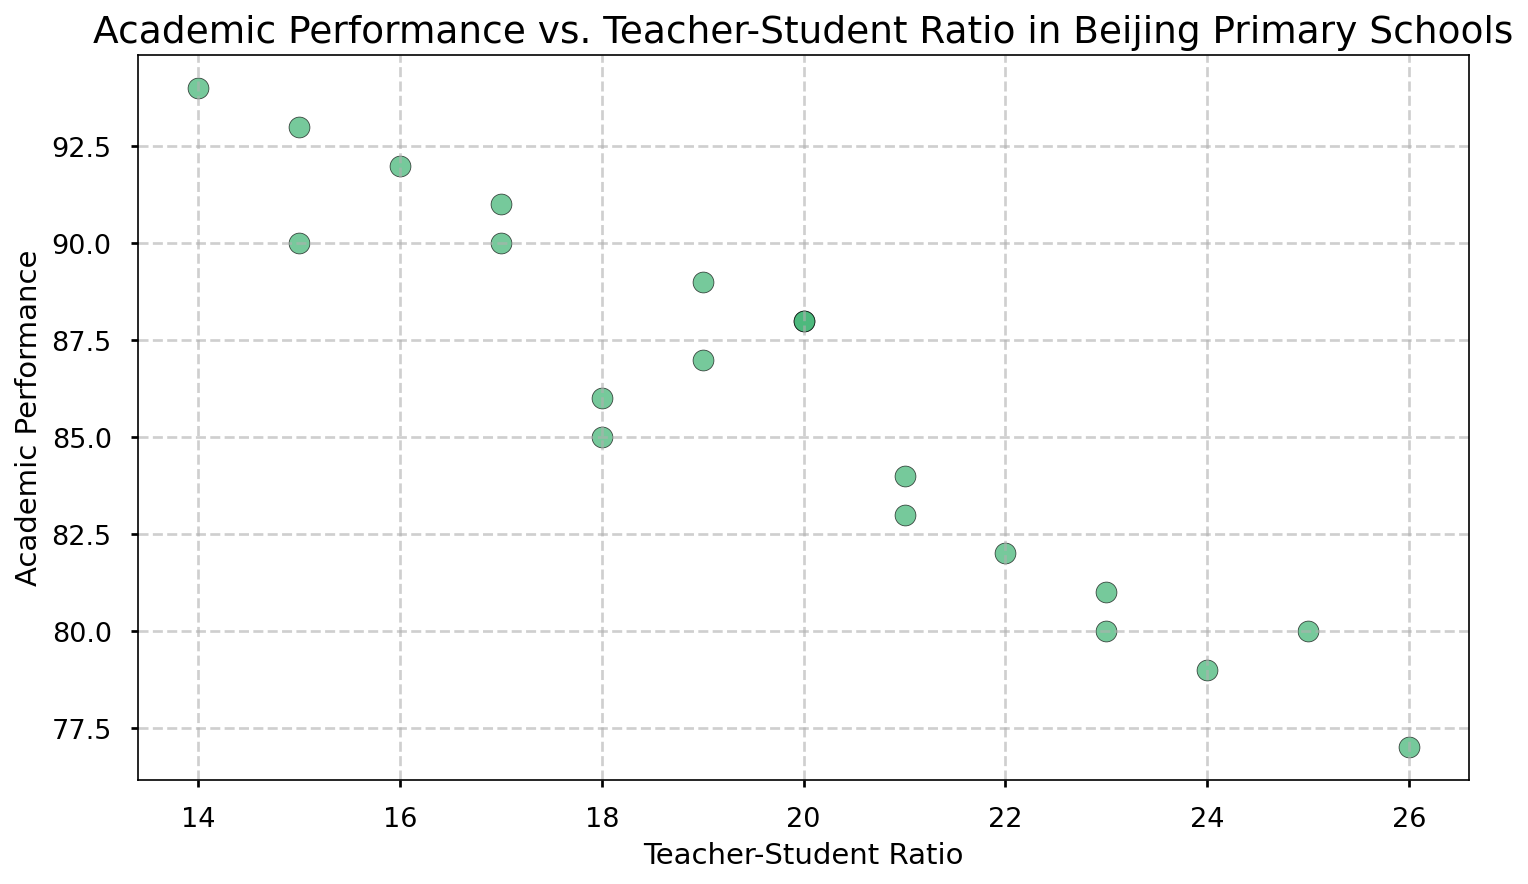What's the relationship between Teacher-Student Ratio and Academic Performance in the scatter plot? The scatter plot shows how Teacher-Student Ratio and Academic Performance vary among Beijing primary schools. By observing the trend in the data points, a general pattern can be discerned, where lower Teacher-Student Ratios tend to correlate with higher Academic Performance. This is evident as schools with lower ratios, such as 14 or 15, generally show higher performance values like 94 and 93.
Answer: Lower Ratio, Higher Performance Which school has the highest Academic Performance, and what is its Teacher-Student Ratio? By identifying the data point with the highest y-coordinate (Academic Performance) in the scatter plot, we see that Beijing Primary School G has the highest Academic Performance of 94. Its Teacher-Student Ratio (x-coordinate) is 14.
Answer: Beijing Primary School G, Ratio: 14 Which schools have Academic Performance above 90, and what are their Teacher-Student Ratios? In the scatter plot, data points above the 90 on the y-axis are noted. The corresponding Teacher-Student Ratios for these data points are then identified: School G (14), School F (16), School K (17), School A (15), and School P (15).
Answer: Schools: G, F, K, A, P; Ratios: 14, 16, 17, 15, 15 Is there a significant difference in Academic Performance between schools with Teacher-Student Ratios of 20 and 25? Observing the data points corresponding to Teacher-Student Ratios of 20 and 25, we see that schools at the ratio of 20 have Academic Performances of 88 and 88 (Schools C and N), whereas schools at the ratio of 25 have a performance of 80 (School D). The difference is noticeable: 88 - 80 = 8 points.
Answer: 8 points Which school has both the lowest Academic Performance and the highest Teacher-Student Ratio? By finding the data point with the lowest y-coordinate (Academic Performance) and highest x-coordinate (Teacher-Student Ratio) simultaneously, we determine that Beijing Primary School O has the lowest performance (77) and the highest ratio (26).
Answer: Beijing Primary School O What is the average Teacher-Student Ratio for schools with Academic Performance scores less than 80? We first identify the data points where Academic Performance is less than 80: 79 (School L), 77 (School O), 80 (School D, School R). Summing their Ratios: 24 + 26 + 25 + 23 = 98. Number of schools: 4. The average = 98 / 4.
Answer: 24.5 How many schools have a Teacher-Student Ratio exactly equal to 18, and what are their Academic Performance scores? By locating the data points where the x-coordinate (Teacher-Student Ratio) is 18, we find two points. Their y-coordinates (Academic Performance) are 85 (School B) and 86 (School M).
Answer: 2 Schools; Scores: 85, 86 What visual trend is noticeable when comparing the Teacher-Student Ratios and Academic Performances across all schools? The scatter plot generally shows that as the Teacher-Student Ratio increases, the points tend to be lower on the y-axis, indicating that higher ratios typically correlate with lower Academic Performance. This visual trend can be seen as a downward-sloping pattern from left to right.
Answer: Higher Ratio, Lower Performance 